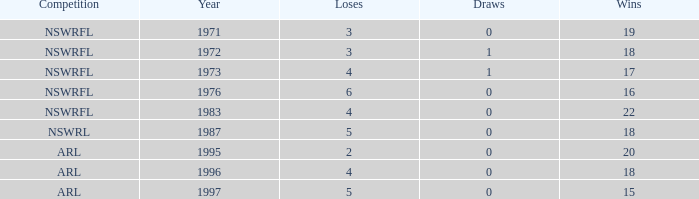What highest Year has Wins 15 and Losses less than 5? None. 